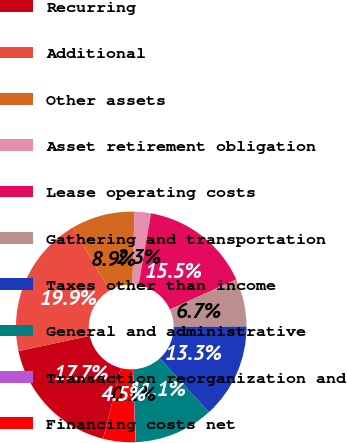<chart> <loc_0><loc_0><loc_500><loc_500><pie_chart><fcel>Recurring<fcel>Additional<fcel>Other assets<fcel>Asset retirement obligation<fcel>Lease operating costs<fcel>Gathering and transportation<fcel>Taxes other than income<fcel>General and administrative<fcel>Transaction reorganization and<fcel>Financing costs net<nl><fcel>17.7%<fcel>19.91%<fcel>8.9%<fcel>2.3%<fcel>15.5%<fcel>6.7%<fcel>13.3%<fcel>11.1%<fcel>0.09%<fcel>4.5%<nl></chart> 